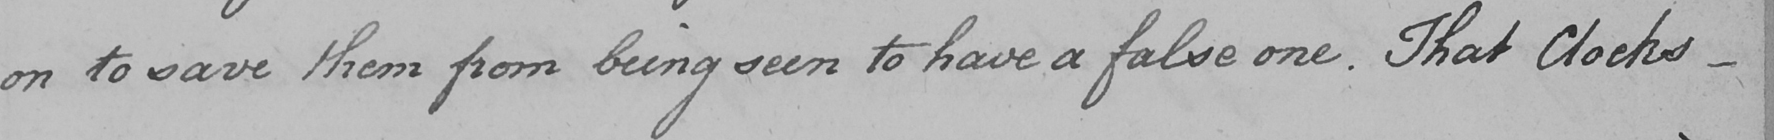Transcribe the text shown in this historical manuscript line. on to save them from being seen to have a false one . That Clocks  _ 